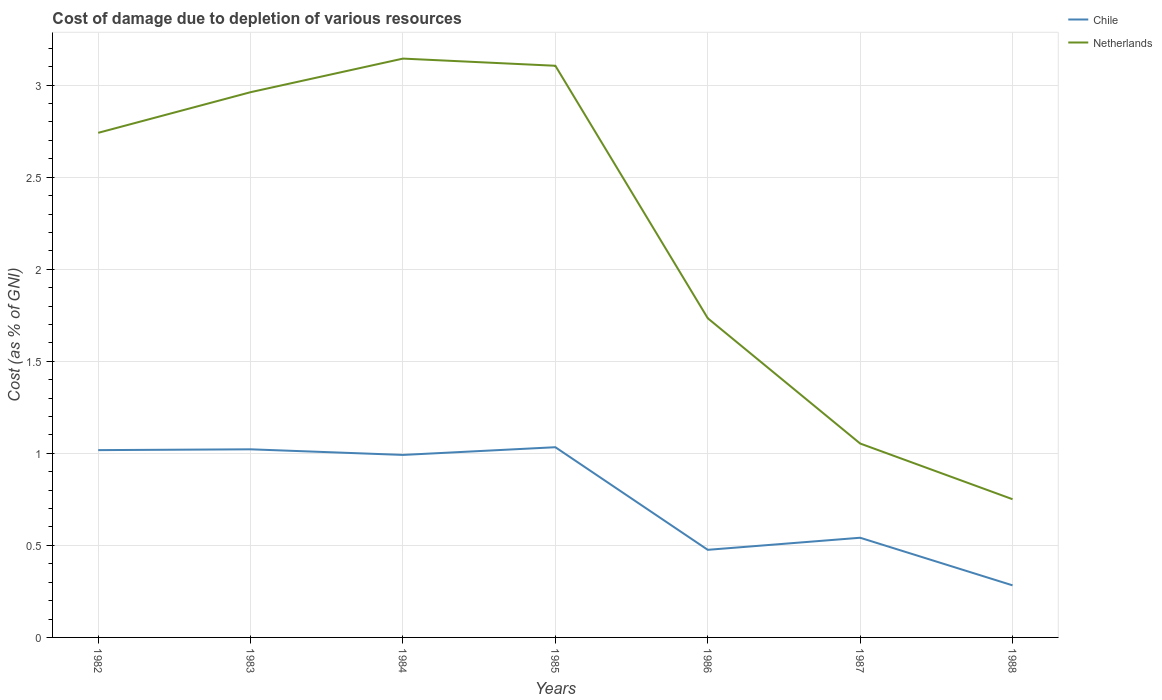How many different coloured lines are there?
Ensure brevity in your answer.  2. Is the number of lines equal to the number of legend labels?
Make the answer very short. Yes. Across all years, what is the maximum cost of damage caused due to the depletion of various resources in Netherlands?
Make the answer very short. 0.75. In which year was the cost of damage caused due to the depletion of various resources in Netherlands maximum?
Provide a short and direct response. 1988. What is the total cost of damage caused due to the depletion of various resources in Chile in the graph?
Provide a succinct answer. 0.55. What is the difference between the highest and the second highest cost of damage caused due to the depletion of various resources in Chile?
Your response must be concise. 0.75. What is the difference between the highest and the lowest cost of damage caused due to the depletion of various resources in Chile?
Your answer should be very brief. 4. Is the cost of damage caused due to the depletion of various resources in Chile strictly greater than the cost of damage caused due to the depletion of various resources in Netherlands over the years?
Provide a short and direct response. Yes. How many lines are there?
Your response must be concise. 2. Are the values on the major ticks of Y-axis written in scientific E-notation?
Your response must be concise. No. Where does the legend appear in the graph?
Provide a short and direct response. Top right. What is the title of the graph?
Your answer should be very brief. Cost of damage due to depletion of various resources. Does "Haiti" appear as one of the legend labels in the graph?
Offer a very short reply. No. What is the label or title of the Y-axis?
Your response must be concise. Cost (as % of GNI). What is the Cost (as % of GNI) in Chile in 1982?
Ensure brevity in your answer.  1.02. What is the Cost (as % of GNI) in Netherlands in 1982?
Your answer should be very brief. 2.74. What is the Cost (as % of GNI) of Chile in 1983?
Offer a terse response. 1.02. What is the Cost (as % of GNI) of Netherlands in 1983?
Ensure brevity in your answer.  2.96. What is the Cost (as % of GNI) in Chile in 1984?
Your answer should be compact. 0.99. What is the Cost (as % of GNI) of Netherlands in 1984?
Provide a short and direct response. 3.14. What is the Cost (as % of GNI) of Chile in 1985?
Give a very brief answer. 1.03. What is the Cost (as % of GNI) of Netherlands in 1985?
Offer a terse response. 3.11. What is the Cost (as % of GNI) of Chile in 1986?
Offer a very short reply. 0.48. What is the Cost (as % of GNI) in Netherlands in 1986?
Make the answer very short. 1.73. What is the Cost (as % of GNI) of Chile in 1987?
Keep it short and to the point. 0.54. What is the Cost (as % of GNI) in Netherlands in 1987?
Keep it short and to the point. 1.05. What is the Cost (as % of GNI) in Chile in 1988?
Offer a terse response. 0.28. What is the Cost (as % of GNI) of Netherlands in 1988?
Keep it short and to the point. 0.75. Across all years, what is the maximum Cost (as % of GNI) of Chile?
Offer a terse response. 1.03. Across all years, what is the maximum Cost (as % of GNI) of Netherlands?
Your answer should be compact. 3.14. Across all years, what is the minimum Cost (as % of GNI) in Chile?
Provide a short and direct response. 0.28. Across all years, what is the minimum Cost (as % of GNI) in Netherlands?
Offer a terse response. 0.75. What is the total Cost (as % of GNI) of Chile in the graph?
Keep it short and to the point. 5.36. What is the total Cost (as % of GNI) of Netherlands in the graph?
Offer a terse response. 15.49. What is the difference between the Cost (as % of GNI) in Chile in 1982 and that in 1983?
Give a very brief answer. -0. What is the difference between the Cost (as % of GNI) in Netherlands in 1982 and that in 1983?
Your answer should be compact. -0.22. What is the difference between the Cost (as % of GNI) in Chile in 1982 and that in 1984?
Offer a very short reply. 0.03. What is the difference between the Cost (as % of GNI) in Netherlands in 1982 and that in 1984?
Ensure brevity in your answer.  -0.4. What is the difference between the Cost (as % of GNI) of Chile in 1982 and that in 1985?
Make the answer very short. -0.02. What is the difference between the Cost (as % of GNI) in Netherlands in 1982 and that in 1985?
Keep it short and to the point. -0.36. What is the difference between the Cost (as % of GNI) of Chile in 1982 and that in 1986?
Provide a short and direct response. 0.54. What is the difference between the Cost (as % of GNI) in Netherlands in 1982 and that in 1986?
Offer a terse response. 1.01. What is the difference between the Cost (as % of GNI) of Chile in 1982 and that in 1987?
Your answer should be very brief. 0.48. What is the difference between the Cost (as % of GNI) in Netherlands in 1982 and that in 1987?
Keep it short and to the point. 1.69. What is the difference between the Cost (as % of GNI) in Chile in 1982 and that in 1988?
Keep it short and to the point. 0.73. What is the difference between the Cost (as % of GNI) of Netherlands in 1982 and that in 1988?
Offer a terse response. 1.99. What is the difference between the Cost (as % of GNI) of Chile in 1983 and that in 1984?
Offer a very short reply. 0.03. What is the difference between the Cost (as % of GNI) of Netherlands in 1983 and that in 1984?
Your answer should be compact. -0.18. What is the difference between the Cost (as % of GNI) in Chile in 1983 and that in 1985?
Offer a terse response. -0.01. What is the difference between the Cost (as % of GNI) in Netherlands in 1983 and that in 1985?
Offer a terse response. -0.14. What is the difference between the Cost (as % of GNI) of Chile in 1983 and that in 1986?
Ensure brevity in your answer.  0.55. What is the difference between the Cost (as % of GNI) of Netherlands in 1983 and that in 1986?
Offer a terse response. 1.23. What is the difference between the Cost (as % of GNI) in Chile in 1983 and that in 1987?
Provide a short and direct response. 0.48. What is the difference between the Cost (as % of GNI) in Netherlands in 1983 and that in 1987?
Make the answer very short. 1.91. What is the difference between the Cost (as % of GNI) of Chile in 1983 and that in 1988?
Your answer should be compact. 0.74. What is the difference between the Cost (as % of GNI) of Netherlands in 1983 and that in 1988?
Ensure brevity in your answer.  2.21. What is the difference between the Cost (as % of GNI) of Chile in 1984 and that in 1985?
Ensure brevity in your answer.  -0.04. What is the difference between the Cost (as % of GNI) in Netherlands in 1984 and that in 1985?
Ensure brevity in your answer.  0.04. What is the difference between the Cost (as % of GNI) in Chile in 1984 and that in 1986?
Your answer should be compact. 0.52. What is the difference between the Cost (as % of GNI) in Netherlands in 1984 and that in 1986?
Offer a terse response. 1.41. What is the difference between the Cost (as % of GNI) in Chile in 1984 and that in 1987?
Your response must be concise. 0.45. What is the difference between the Cost (as % of GNI) of Netherlands in 1984 and that in 1987?
Offer a terse response. 2.09. What is the difference between the Cost (as % of GNI) in Chile in 1984 and that in 1988?
Provide a short and direct response. 0.71. What is the difference between the Cost (as % of GNI) of Netherlands in 1984 and that in 1988?
Your answer should be very brief. 2.39. What is the difference between the Cost (as % of GNI) of Chile in 1985 and that in 1986?
Your answer should be compact. 0.56. What is the difference between the Cost (as % of GNI) of Netherlands in 1985 and that in 1986?
Make the answer very short. 1.37. What is the difference between the Cost (as % of GNI) in Chile in 1985 and that in 1987?
Your answer should be compact. 0.49. What is the difference between the Cost (as % of GNI) in Netherlands in 1985 and that in 1987?
Your answer should be compact. 2.05. What is the difference between the Cost (as % of GNI) in Chile in 1985 and that in 1988?
Give a very brief answer. 0.75. What is the difference between the Cost (as % of GNI) of Netherlands in 1985 and that in 1988?
Your answer should be compact. 2.35. What is the difference between the Cost (as % of GNI) in Chile in 1986 and that in 1987?
Give a very brief answer. -0.07. What is the difference between the Cost (as % of GNI) of Netherlands in 1986 and that in 1987?
Your answer should be compact. 0.68. What is the difference between the Cost (as % of GNI) in Chile in 1986 and that in 1988?
Keep it short and to the point. 0.19. What is the difference between the Cost (as % of GNI) of Chile in 1987 and that in 1988?
Provide a short and direct response. 0.26. What is the difference between the Cost (as % of GNI) in Netherlands in 1987 and that in 1988?
Offer a terse response. 0.3. What is the difference between the Cost (as % of GNI) of Chile in 1982 and the Cost (as % of GNI) of Netherlands in 1983?
Your answer should be very brief. -1.94. What is the difference between the Cost (as % of GNI) of Chile in 1982 and the Cost (as % of GNI) of Netherlands in 1984?
Offer a very short reply. -2.13. What is the difference between the Cost (as % of GNI) in Chile in 1982 and the Cost (as % of GNI) in Netherlands in 1985?
Keep it short and to the point. -2.09. What is the difference between the Cost (as % of GNI) in Chile in 1982 and the Cost (as % of GNI) in Netherlands in 1986?
Your answer should be very brief. -0.72. What is the difference between the Cost (as % of GNI) in Chile in 1982 and the Cost (as % of GNI) in Netherlands in 1987?
Ensure brevity in your answer.  -0.04. What is the difference between the Cost (as % of GNI) in Chile in 1982 and the Cost (as % of GNI) in Netherlands in 1988?
Your answer should be compact. 0.27. What is the difference between the Cost (as % of GNI) of Chile in 1983 and the Cost (as % of GNI) of Netherlands in 1984?
Ensure brevity in your answer.  -2.12. What is the difference between the Cost (as % of GNI) of Chile in 1983 and the Cost (as % of GNI) of Netherlands in 1985?
Your answer should be very brief. -2.08. What is the difference between the Cost (as % of GNI) of Chile in 1983 and the Cost (as % of GNI) of Netherlands in 1986?
Offer a very short reply. -0.71. What is the difference between the Cost (as % of GNI) of Chile in 1983 and the Cost (as % of GNI) of Netherlands in 1987?
Offer a very short reply. -0.03. What is the difference between the Cost (as % of GNI) in Chile in 1983 and the Cost (as % of GNI) in Netherlands in 1988?
Ensure brevity in your answer.  0.27. What is the difference between the Cost (as % of GNI) in Chile in 1984 and the Cost (as % of GNI) in Netherlands in 1985?
Your answer should be very brief. -2.11. What is the difference between the Cost (as % of GNI) of Chile in 1984 and the Cost (as % of GNI) of Netherlands in 1986?
Your response must be concise. -0.74. What is the difference between the Cost (as % of GNI) of Chile in 1984 and the Cost (as % of GNI) of Netherlands in 1987?
Provide a succinct answer. -0.06. What is the difference between the Cost (as % of GNI) of Chile in 1984 and the Cost (as % of GNI) of Netherlands in 1988?
Offer a very short reply. 0.24. What is the difference between the Cost (as % of GNI) in Chile in 1985 and the Cost (as % of GNI) in Netherlands in 1986?
Ensure brevity in your answer.  -0.7. What is the difference between the Cost (as % of GNI) in Chile in 1985 and the Cost (as % of GNI) in Netherlands in 1987?
Make the answer very short. -0.02. What is the difference between the Cost (as % of GNI) in Chile in 1985 and the Cost (as % of GNI) in Netherlands in 1988?
Make the answer very short. 0.28. What is the difference between the Cost (as % of GNI) in Chile in 1986 and the Cost (as % of GNI) in Netherlands in 1987?
Your response must be concise. -0.58. What is the difference between the Cost (as % of GNI) of Chile in 1986 and the Cost (as % of GNI) of Netherlands in 1988?
Offer a terse response. -0.27. What is the difference between the Cost (as % of GNI) in Chile in 1987 and the Cost (as % of GNI) in Netherlands in 1988?
Your answer should be very brief. -0.21. What is the average Cost (as % of GNI) in Chile per year?
Provide a succinct answer. 0.77. What is the average Cost (as % of GNI) of Netherlands per year?
Provide a short and direct response. 2.21. In the year 1982, what is the difference between the Cost (as % of GNI) in Chile and Cost (as % of GNI) in Netherlands?
Make the answer very short. -1.72. In the year 1983, what is the difference between the Cost (as % of GNI) of Chile and Cost (as % of GNI) of Netherlands?
Keep it short and to the point. -1.94. In the year 1984, what is the difference between the Cost (as % of GNI) of Chile and Cost (as % of GNI) of Netherlands?
Offer a terse response. -2.15. In the year 1985, what is the difference between the Cost (as % of GNI) of Chile and Cost (as % of GNI) of Netherlands?
Provide a short and direct response. -2.07. In the year 1986, what is the difference between the Cost (as % of GNI) of Chile and Cost (as % of GNI) of Netherlands?
Provide a succinct answer. -1.26. In the year 1987, what is the difference between the Cost (as % of GNI) of Chile and Cost (as % of GNI) of Netherlands?
Ensure brevity in your answer.  -0.51. In the year 1988, what is the difference between the Cost (as % of GNI) of Chile and Cost (as % of GNI) of Netherlands?
Keep it short and to the point. -0.47. What is the ratio of the Cost (as % of GNI) in Chile in 1982 to that in 1983?
Make the answer very short. 1. What is the ratio of the Cost (as % of GNI) of Netherlands in 1982 to that in 1983?
Offer a terse response. 0.93. What is the ratio of the Cost (as % of GNI) of Chile in 1982 to that in 1984?
Ensure brevity in your answer.  1.03. What is the ratio of the Cost (as % of GNI) of Netherlands in 1982 to that in 1984?
Your response must be concise. 0.87. What is the ratio of the Cost (as % of GNI) of Chile in 1982 to that in 1985?
Your answer should be compact. 0.98. What is the ratio of the Cost (as % of GNI) in Netherlands in 1982 to that in 1985?
Provide a short and direct response. 0.88. What is the ratio of the Cost (as % of GNI) of Chile in 1982 to that in 1986?
Your response must be concise. 2.14. What is the ratio of the Cost (as % of GNI) of Netherlands in 1982 to that in 1986?
Offer a very short reply. 1.58. What is the ratio of the Cost (as % of GNI) of Chile in 1982 to that in 1987?
Your answer should be compact. 1.88. What is the ratio of the Cost (as % of GNI) in Netherlands in 1982 to that in 1987?
Offer a terse response. 2.6. What is the ratio of the Cost (as % of GNI) in Chile in 1982 to that in 1988?
Provide a short and direct response. 3.6. What is the ratio of the Cost (as % of GNI) of Netherlands in 1982 to that in 1988?
Offer a terse response. 3.65. What is the ratio of the Cost (as % of GNI) of Chile in 1983 to that in 1984?
Provide a short and direct response. 1.03. What is the ratio of the Cost (as % of GNI) in Netherlands in 1983 to that in 1984?
Provide a short and direct response. 0.94. What is the ratio of the Cost (as % of GNI) of Netherlands in 1983 to that in 1985?
Give a very brief answer. 0.95. What is the ratio of the Cost (as % of GNI) of Chile in 1983 to that in 1986?
Your answer should be compact. 2.15. What is the ratio of the Cost (as % of GNI) of Netherlands in 1983 to that in 1986?
Give a very brief answer. 1.71. What is the ratio of the Cost (as % of GNI) of Chile in 1983 to that in 1987?
Provide a short and direct response. 1.89. What is the ratio of the Cost (as % of GNI) of Netherlands in 1983 to that in 1987?
Offer a terse response. 2.81. What is the ratio of the Cost (as % of GNI) in Chile in 1983 to that in 1988?
Offer a terse response. 3.61. What is the ratio of the Cost (as % of GNI) in Netherlands in 1983 to that in 1988?
Your response must be concise. 3.94. What is the ratio of the Cost (as % of GNI) in Chile in 1984 to that in 1985?
Your answer should be very brief. 0.96. What is the ratio of the Cost (as % of GNI) in Netherlands in 1984 to that in 1985?
Provide a short and direct response. 1.01. What is the ratio of the Cost (as % of GNI) in Chile in 1984 to that in 1986?
Your answer should be very brief. 2.08. What is the ratio of the Cost (as % of GNI) of Netherlands in 1984 to that in 1986?
Your answer should be very brief. 1.81. What is the ratio of the Cost (as % of GNI) of Chile in 1984 to that in 1987?
Keep it short and to the point. 1.83. What is the ratio of the Cost (as % of GNI) of Netherlands in 1984 to that in 1987?
Ensure brevity in your answer.  2.99. What is the ratio of the Cost (as % of GNI) in Chile in 1984 to that in 1988?
Keep it short and to the point. 3.5. What is the ratio of the Cost (as % of GNI) in Netherlands in 1984 to that in 1988?
Provide a short and direct response. 4.19. What is the ratio of the Cost (as % of GNI) in Chile in 1985 to that in 1986?
Your response must be concise. 2.17. What is the ratio of the Cost (as % of GNI) in Netherlands in 1985 to that in 1986?
Offer a terse response. 1.79. What is the ratio of the Cost (as % of GNI) in Chile in 1985 to that in 1987?
Offer a very short reply. 1.91. What is the ratio of the Cost (as % of GNI) of Netherlands in 1985 to that in 1987?
Keep it short and to the point. 2.95. What is the ratio of the Cost (as % of GNI) of Chile in 1985 to that in 1988?
Offer a terse response. 3.65. What is the ratio of the Cost (as % of GNI) in Netherlands in 1985 to that in 1988?
Give a very brief answer. 4.14. What is the ratio of the Cost (as % of GNI) of Chile in 1986 to that in 1987?
Provide a short and direct response. 0.88. What is the ratio of the Cost (as % of GNI) of Netherlands in 1986 to that in 1987?
Provide a short and direct response. 1.65. What is the ratio of the Cost (as % of GNI) of Chile in 1986 to that in 1988?
Offer a terse response. 1.68. What is the ratio of the Cost (as % of GNI) of Netherlands in 1986 to that in 1988?
Provide a succinct answer. 2.31. What is the ratio of the Cost (as % of GNI) of Chile in 1987 to that in 1988?
Your answer should be very brief. 1.91. What is the ratio of the Cost (as % of GNI) of Netherlands in 1987 to that in 1988?
Your response must be concise. 1.4. What is the difference between the highest and the second highest Cost (as % of GNI) in Chile?
Your answer should be compact. 0.01. What is the difference between the highest and the second highest Cost (as % of GNI) of Netherlands?
Provide a succinct answer. 0.04. What is the difference between the highest and the lowest Cost (as % of GNI) of Chile?
Your answer should be compact. 0.75. What is the difference between the highest and the lowest Cost (as % of GNI) of Netherlands?
Your response must be concise. 2.39. 